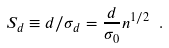<formula> <loc_0><loc_0><loc_500><loc_500>S _ { d } \equiv d / \sigma _ { d } = \frac { d } { \sigma _ { 0 } } n ^ { 1 / 2 } \ .</formula> 